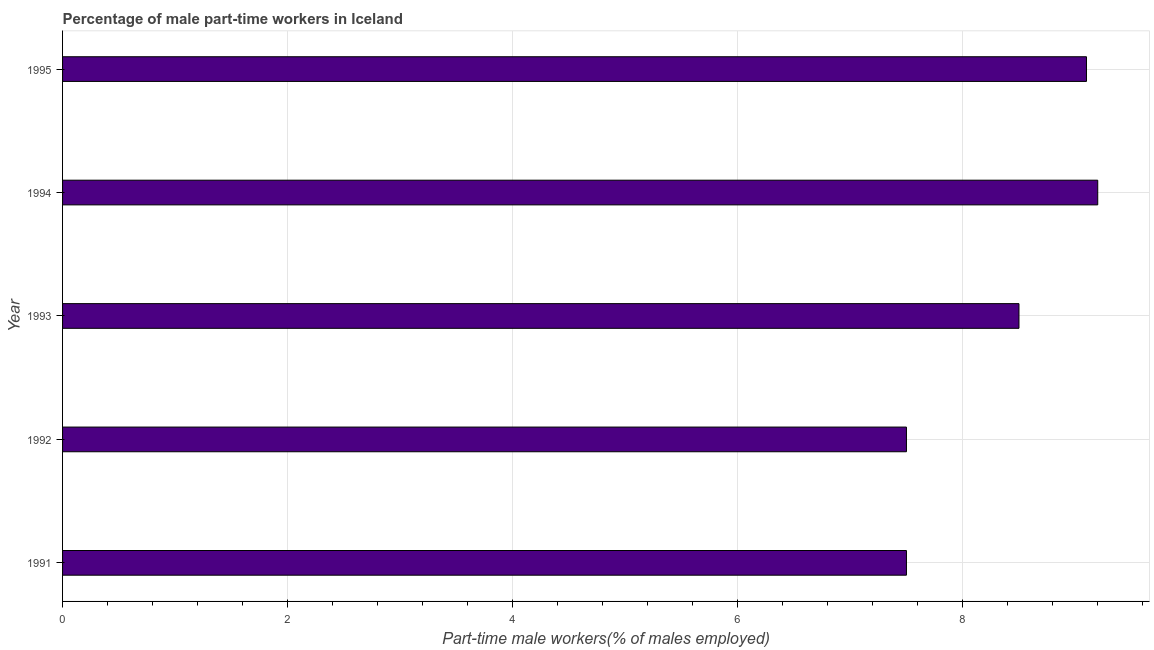Does the graph contain any zero values?
Your response must be concise. No. Does the graph contain grids?
Your answer should be compact. Yes. What is the title of the graph?
Offer a very short reply. Percentage of male part-time workers in Iceland. What is the label or title of the X-axis?
Offer a terse response. Part-time male workers(% of males employed). What is the label or title of the Y-axis?
Make the answer very short. Year. Across all years, what is the maximum percentage of part-time male workers?
Provide a short and direct response. 9.2. In which year was the percentage of part-time male workers maximum?
Make the answer very short. 1994. What is the sum of the percentage of part-time male workers?
Your answer should be very brief. 41.8. What is the average percentage of part-time male workers per year?
Offer a terse response. 8.36. What is the ratio of the percentage of part-time male workers in 1993 to that in 1994?
Ensure brevity in your answer.  0.92. Is the sum of the percentage of part-time male workers in 1991 and 1994 greater than the maximum percentage of part-time male workers across all years?
Make the answer very short. Yes. How many bars are there?
Give a very brief answer. 5. What is the Part-time male workers(% of males employed) of 1991?
Your answer should be very brief. 7.5. What is the Part-time male workers(% of males employed) in 1994?
Make the answer very short. 9.2. What is the Part-time male workers(% of males employed) of 1995?
Offer a terse response. 9.1. What is the difference between the Part-time male workers(% of males employed) in 1991 and 1994?
Provide a succinct answer. -1.7. What is the difference between the Part-time male workers(% of males employed) in 1991 and 1995?
Give a very brief answer. -1.6. What is the difference between the Part-time male workers(% of males employed) in 1992 and 1993?
Offer a terse response. -1. What is the difference between the Part-time male workers(% of males employed) in 1992 and 1994?
Give a very brief answer. -1.7. What is the difference between the Part-time male workers(% of males employed) in 1992 and 1995?
Provide a short and direct response. -1.6. What is the ratio of the Part-time male workers(% of males employed) in 1991 to that in 1992?
Your answer should be compact. 1. What is the ratio of the Part-time male workers(% of males employed) in 1991 to that in 1993?
Make the answer very short. 0.88. What is the ratio of the Part-time male workers(% of males employed) in 1991 to that in 1994?
Provide a short and direct response. 0.81. What is the ratio of the Part-time male workers(% of males employed) in 1991 to that in 1995?
Your response must be concise. 0.82. What is the ratio of the Part-time male workers(% of males employed) in 1992 to that in 1993?
Your answer should be very brief. 0.88. What is the ratio of the Part-time male workers(% of males employed) in 1992 to that in 1994?
Keep it short and to the point. 0.81. What is the ratio of the Part-time male workers(% of males employed) in 1992 to that in 1995?
Provide a short and direct response. 0.82. What is the ratio of the Part-time male workers(% of males employed) in 1993 to that in 1994?
Provide a succinct answer. 0.92. What is the ratio of the Part-time male workers(% of males employed) in 1993 to that in 1995?
Make the answer very short. 0.93. What is the ratio of the Part-time male workers(% of males employed) in 1994 to that in 1995?
Keep it short and to the point. 1.01. 